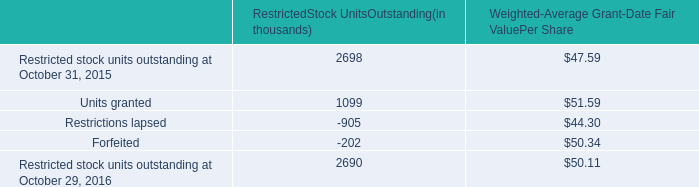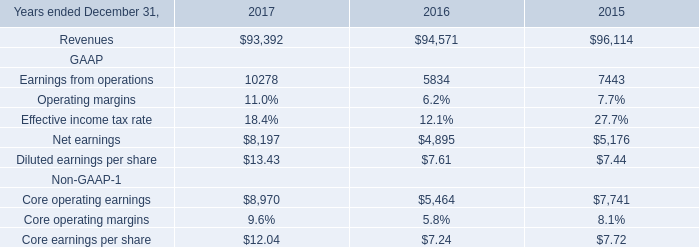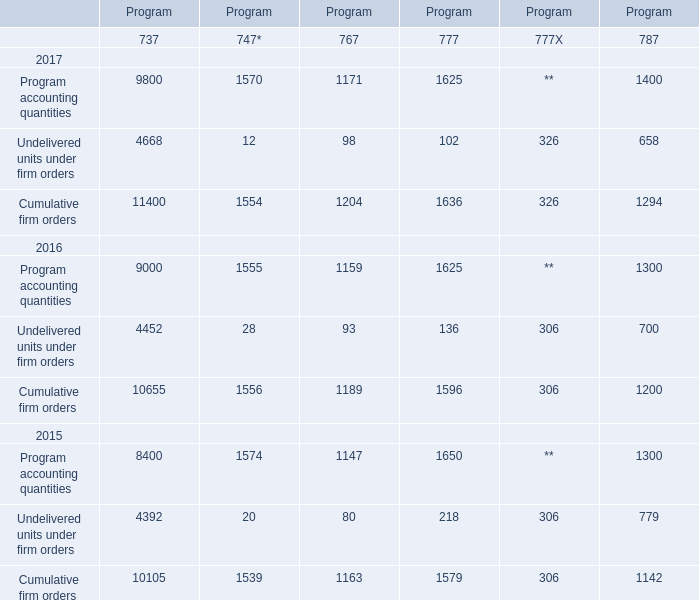If program accounting quantities of 737 develops with the same increasing rate in 2017, what will it reach in 2018? 
Computations: (9800 * (1 + ((9800 - 9000) / 9000)))
Answer: 10671.11111. 